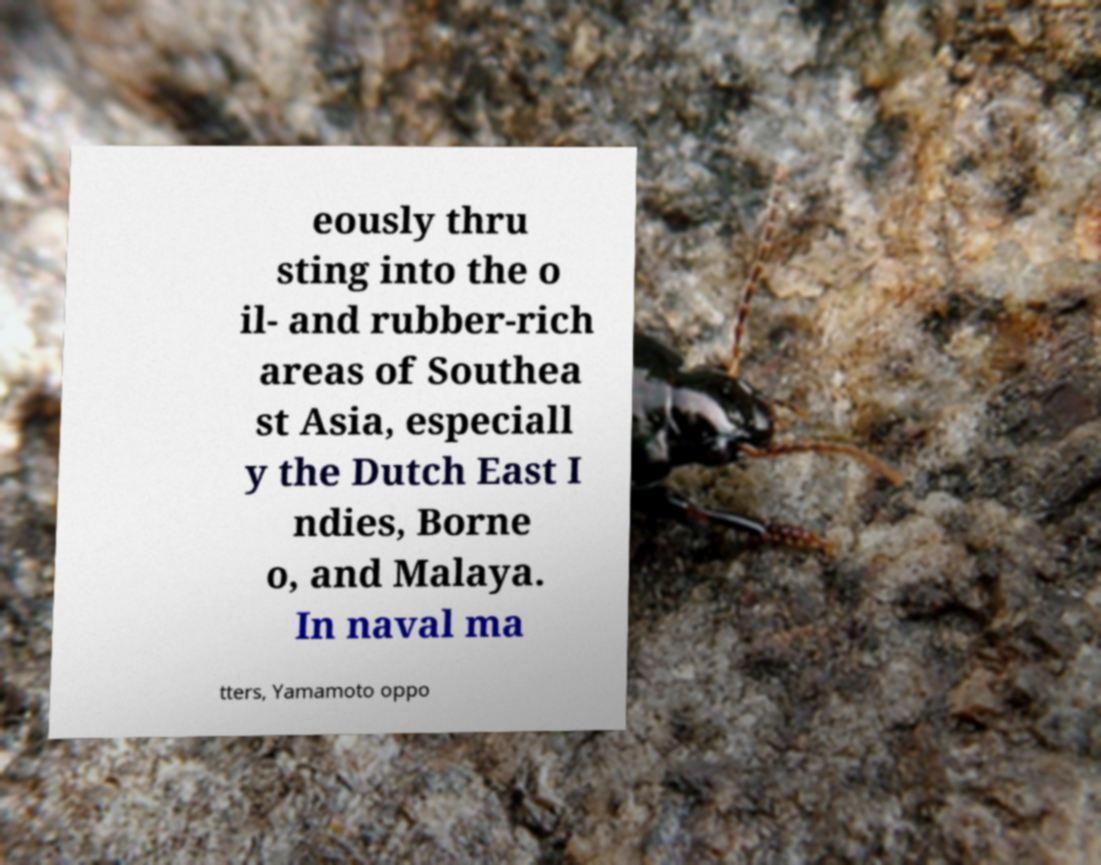Please read and relay the text visible in this image. What does it say? eously thru sting into the o il- and rubber-rich areas of Southea st Asia, especiall y the Dutch East I ndies, Borne o, and Malaya. In naval ma tters, Yamamoto oppo 